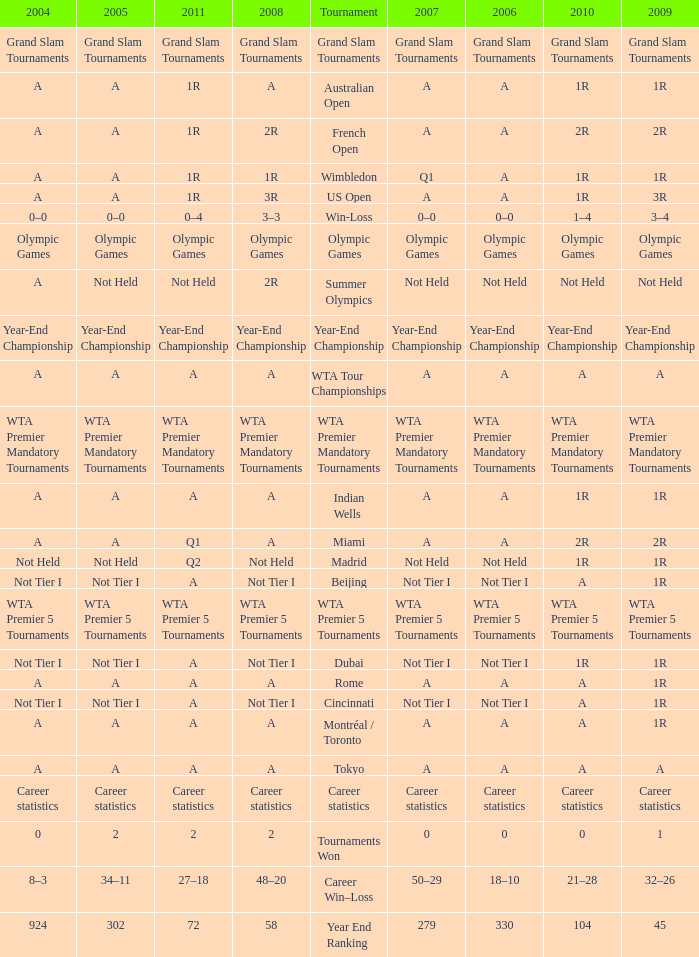What is 2004, when 2008 is "WTA Premier 5 Tournaments"? WTA Premier 5 Tournaments. 